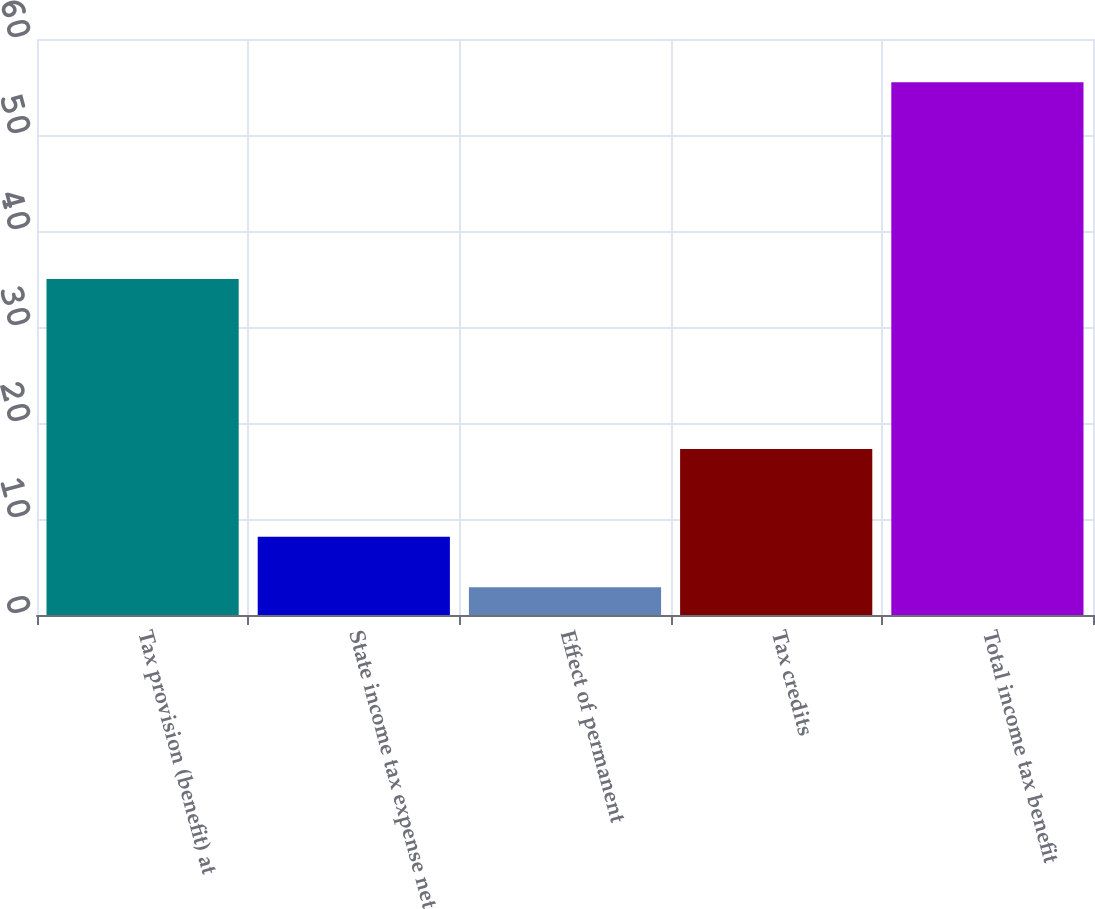Convert chart to OTSL. <chart><loc_0><loc_0><loc_500><loc_500><bar_chart><fcel>Tax provision (benefit) at<fcel>State income tax expense net<fcel>Effect of permanent<fcel>Tax credits<fcel>Total income tax benefit<nl><fcel>35<fcel>8.16<fcel>2.9<fcel>17.3<fcel>55.5<nl></chart> 